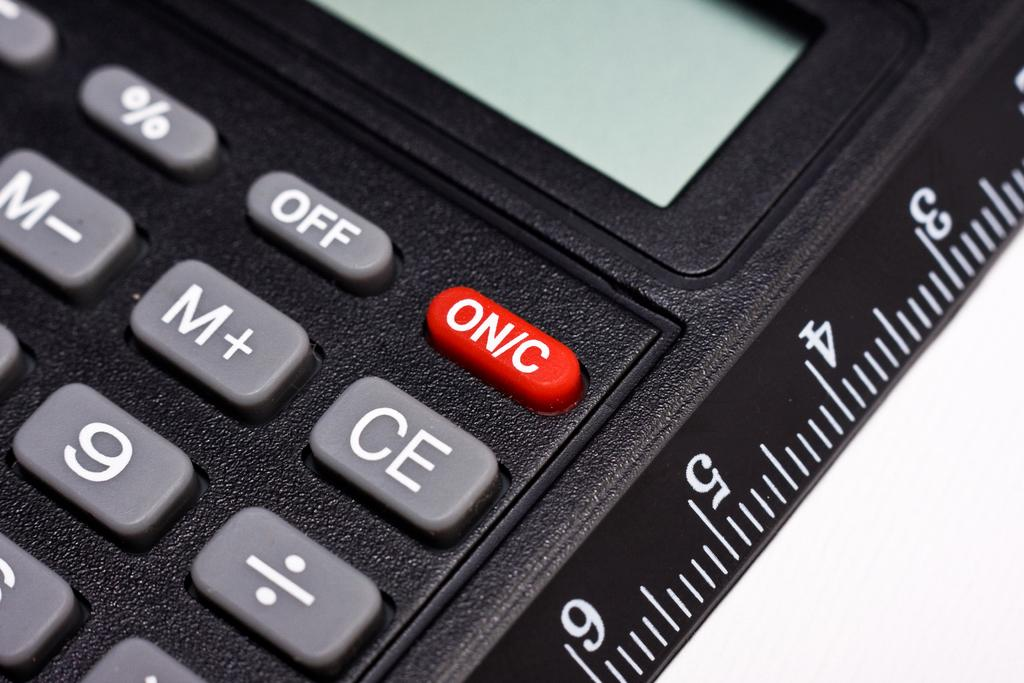<image>
Write a terse but informative summary of the picture. A black calculator features buttons labelled "off" and "on/c" 